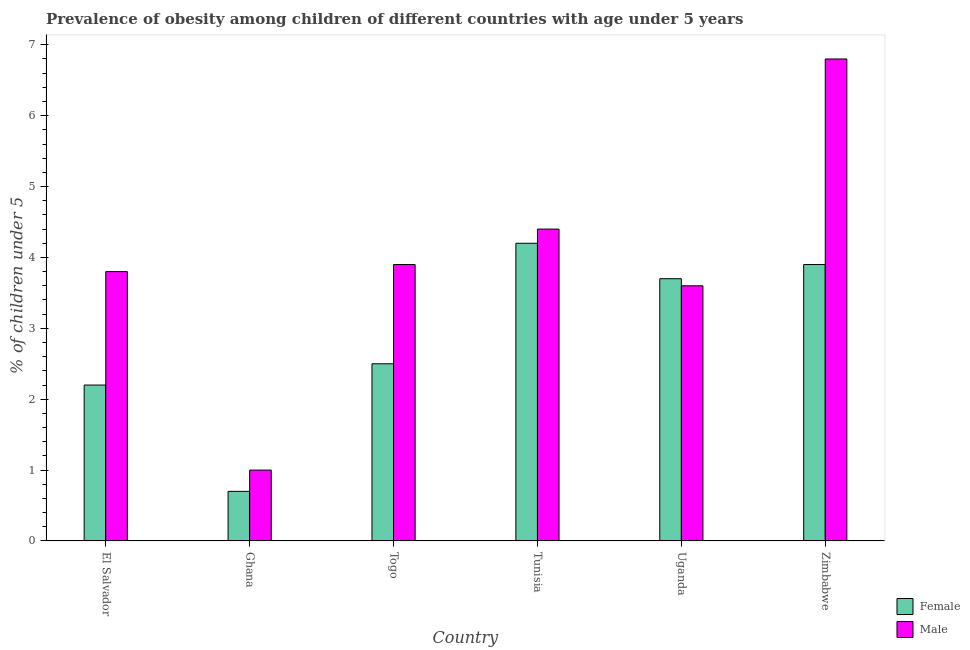How many different coloured bars are there?
Keep it short and to the point. 2. Are the number of bars per tick equal to the number of legend labels?
Your response must be concise. Yes. What is the percentage of obese female children in El Salvador?
Your answer should be very brief. 2.2. Across all countries, what is the maximum percentage of obese male children?
Provide a short and direct response. 6.8. Across all countries, what is the minimum percentage of obese male children?
Provide a short and direct response. 1. In which country was the percentage of obese female children maximum?
Offer a very short reply. Tunisia. In which country was the percentage of obese male children minimum?
Your answer should be compact. Ghana. What is the total percentage of obese female children in the graph?
Provide a short and direct response. 17.2. What is the difference between the percentage of obese male children in El Salvador and that in Togo?
Offer a terse response. -0.1. What is the difference between the percentage of obese female children in Ghana and the percentage of obese male children in El Salvador?
Keep it short and to the point. -3.1. What is the average percentage of obese male children per country?
Make the answer very short. 3.92. What is the difference between the percentage of obese male children and percentage of obese female children in Zimbabwe?
Give a very brief answer. 2.9. What is the ratio of the percentage of obese female children in El Salvador to that in Tunisia?
Give a very brief answer. 0.52. What is the difference between the highest and the second highest percentage of obese female children?
Provide a succinct answer. 0.3. What is the difference between the highest and the lowest percentage of obese male children?
Make the answer very short. 5.8. What is the difference between two consecutive major ticks on the Y-axis?
Offer a terse response. 1. Are the values on the major ticks of Y-axis written in scientific E-notation?
Ensure brevity in your answer.  No. Where does the legend appear in the graph?
Keep it short and to the point. Bottom right. What is the title of the graph?
Ensure brevity in your answer.  Prevalence of obesity among children of different countries with age under 5 years. What is the label or title of the Y-axis?
Offer a very short reply.  % of children under 5. What is the  % of children under 5 in Female in El Salvador?
Give a very brief answer. 2.2. What is the  % of children under 5 in Male in El Salvador?
Offer a very short reply. 3.8. What is the  % of children under 5 of Female in Ghana?
Make the answer very short. 0.7. What is the  % of children under 5 in Male in Ghana?
Ensure brevity in your answer.  1. What is the  % of children under 5 of Male in Togo?
Give a very brief answer. 3.9. What is the  % of children under 5 in Female in Tunisia?
Your response must be concise. 4.2. What is the  % of children under 5 in Male in Tunisia?
Ensure brevity in your answer.  4.4. What is the  % of children under 5 of Female in Uganda?
Keep it short and to the point. 3.7. What is the  % of children under 5 of Male in Uganda?
Give a very brief answer. 3.6. What is the  % of children under 5 of Female in Zimbabwe?
Your answer should be compact. 3.9. What is the  % of children under 5 of Male in Zimbabwe?
Ensure brevity in your answer.  6.8. Across all countries, what is the maximum  % of children under 5 in Female?
Your answer should be compact. 4.2. Across all countries, what is the maximum  % of children under 5 of Male?
Offer a very short reply. 6.8. Across all countries, what is the minimum  % of children under 5 in Female?
Your answer should be very brief. 0.7. Across all countries, what is the minimum  % of children under 5 of Male?
Your response must be concise. 1. What is the total  % of children under 5 of Male in the graph?
Your response must be concise. 23.5. What is the difference between the  % of children under 5 in Male in El Salvador and that in Ghana?
Your answer should be very brief. 2.8. What is the difference between the  % of children under 5 in Female in El Salvador and that in Togo?
Ensure brevity in your answer.  -0.3. What is the difference between the  % of children under 5 of Male in El Salvador and that in Tunisia?
Offer a very short reply. -0.6. What is the difference between the  % of children under 5 in Female in El Salvador and that in Uganda?
Make the answer very short. -1.5. What is the difference between the  % of children under 5 in Female in El Salvador and that in Zimbabwe?
Your response must be concise. -1.7. What is the difference between the  % of children under 5 in Male in El Salvador and that in Zimbabwe?
Offer a very short reply. -3. What is the difference between the  % of children under 5 of Female in Ghana and that in Togo?
Make the answer very short. -1.8. What is the difference between the  % of children under 5 in Female in Ghana and that in Tunisia?
Give a very brief answer. -3.5. What is the difference between the  % of children under 5 in Male in Ghana and that in Tunisia?
Offer a very short reply. -3.4. What is the difference between the  % of children under 5 of Male in Ghana and that in Uganda?
Your response must be concise. -2.6. What is the difference between the  % of children under 5 of Female in Ghana and that in Zimbabwe?
Provide a short and direct response. -3.2. What is the difference between the  % of children under 5 of Male in Togo and that in Tunisia?
Offer a terse response. -0.5. What is the difference between the  % of children under 5 in Male in Tunisia and that in Uganda?
Provide a succinct answer. 0.8. What is the difference between the  % of children under 5 in Female in Tunisia and that in Zimbabwe?
Keep it short and to the point. 0.3. What is the difference between the  % of children under 5 of Female in El Salvador and the  % of children under 5 of Male in Ghana?
Give a very brief answer. 1.2. What is the difference between the  % of children under 5 in Female in El Salvador and the  % of children under 5 in Male in Togo?
Your answer should be very brief. -1.7. What is the difference between the  % of children under 5 in Female in El Salvador and the  % of children under 5 in Male in Uganda?
Provide a succinct answer. -1.4. What is the difference between the  % of children under 5 of Female in El Salvador and the  % of children under 5 of Male in Zimbabwe?
Give a very brief answer. -4.6. What is the difference between the  % of children under 5 in Female in Ghana and the  % of children under 5 in Male in Tunisia?
Offer a terse response. -3.7. What is the difference between the  % of children under 5 in Female in Ghana and the  % of children under 5 in Male in Zimbabwe?
Provide a short and direct response. -6.1. What is the difference between the  % of children under 5 in Female in Togo and the  % of children under 5 in Male in Uganda?
Your answer should be compact. -1.1. What is the difference between the  % of children under 5 in Female in Uganda and the  % of children under 5 in Male in Zimbabwe?
Your answer should be compact. -3.1. What is the average  % of children under 5 in Female per country?
Make the answer very short. 2.87. What is the average  % of children under 5 in Male per country?
Keep it short and to the point. 3.92. What is the difference between the  % of children under 5 of Female and  % of children under 5 of Male in Tunisia?
Offer a very short reply. -0.2. What is the difference between the  % of children under 5 in Female and  % of children under 5 in Male in Uganda?
Give a very brief answer. 0.1. What is the difference between the  % of children under 5 of Female and  % of children under 5 of Male in Zimbabwe?
Give a very brief answer. -2.9. What is the ratio of the  % of children under 5 of Female in El Salvador to that in Ghana?
Offer a very short reply. 3.14. What is the ratio of the  % of children under 5 of Male in El Salvador to that in Togo?
Make the answer very short. 0.97. What is the ratio of the  % of children under 5 of Female in El Salvador to that in Tunisia?
Your answer should be very brief. 0.52. What is the ratio of the  % of children under 5 of Male in El Salvador to that in Tunisia?
Ensure brevity in your answer.  0.86. What is the ratio of the  % of children under 5 in Female in El Salvador to that in Uganda?
Offer a terse response. 0.59. What is the ratio of the  % of children under 5 in Male in El Salvador to that in Uganda?
Provide a short and direct response. 1.06. What is the ratio of the  % of children under 5 of Female in El Salvador to that in Zimbabwe?
Your answer should be very brief. 0.56. What is the ratio of the  % of children under 5 of Male in El Salvador to that in Zimbabwe?
Keep it short and to the point. 0.56. What is the ratio of the  % of children under 5 of Female in Ghana to that in Togo?
Offer a terse response. 0.28. What is the ratio of the  % of children under 5 in Male in Ghana to that in Togo?
Offer a terse response. 0.26. What is the ratio of the  % of children under 5 in Male in Ghana to that in Tunisia?
Ensure brevity in your answer.  0.23. What is the ratio of the  % of children under 5 in Female in Ghana to that in Uganda?
Provide a succinct answer. 0.19. What is the ratio of the  % of children under 5 in Male in Ghana to that in Uganda?
Your response must be concise. 0.28. What is the ratio of the  % of children under 5 in Female in Ghana to that in Zimbabwe?
Your answer should be very brief. 0.18. What is the ratio of the  % of children under 5 in Male in Ghana to that in Zimbabwe?
Give a very brief answer. 0.15. What is the ratio of the  % of children under 5 in Female in Togo to that in Tunisia?
Make the answer very short. 0.6. What is the ratio of the  % of children under 5 in Male in Togo to that in Tunisia?
Make the answer very short. 0.89. What is the ratio of the  % of children under 5 of Female in Togo to that in Uganda?
Give a very brief answer. 0.68. What is the ratio of the  % of children under 5 of Male in Togo to that in Uganda?
Offer a very short reply. 1.08. What is the ratio of the  % of children under 5 of Female in Togo to that in Zimbabwe?
Provide a short and direct response. 0.64. What is the ratio of the  % of children under 5 in Male in Togo to that in Zimbabwe?
Keep it short and to the point. 0.57. What is the ratio of the  % of children under 5 of Female in Tunisia to that in Uganda?
Offer a very short reply. 1.14. What is the ratio of the  % of children under 5 of Male in Tunisia to that in Uganda?
Give a very brief answer. 1.22. What is the ratio of the  % of children under 5 of Male in Tunisia to that in Zimbabwe?
Give a very brief answer. 0.65. What is the ratio of the  % of children under 5 of Female in Uganda to that in Zimbabwe?
Provide a succinct answer. 0.95. What is the ratio of the  % of children under 5 of Male in Uganda to that in Zimbabwe?
Offer a very short reply. 0.53. What is the difference between the highest and the second highest  % of children under 5 of Female?
Offer a terse response. 0.3. What is the difference between the highest and the second highest  % of children under 5 of Male?
Give a very brief answer. 2.4. What is the difference between the highest and the lowest  % of children under 5 of Male?
Keep it short and to the point. 5.8. 